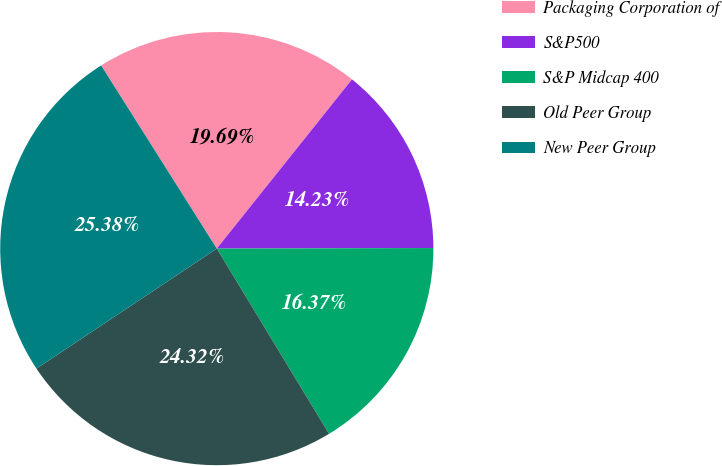Convert chart. <chart><loc_0><loc_0><loc_500><loc_500><pie_chart><fcel>Packaging Corporation of<fcel>S&P500<fcel>S&P Midcap 400<fcel>Old Peer Group<fcel>New Peer Group<nl><fcel>19.69%<fcel>14.23%<fcel>16.37%<fcel>24.32%<fcel>25.38%<nl></chart> 